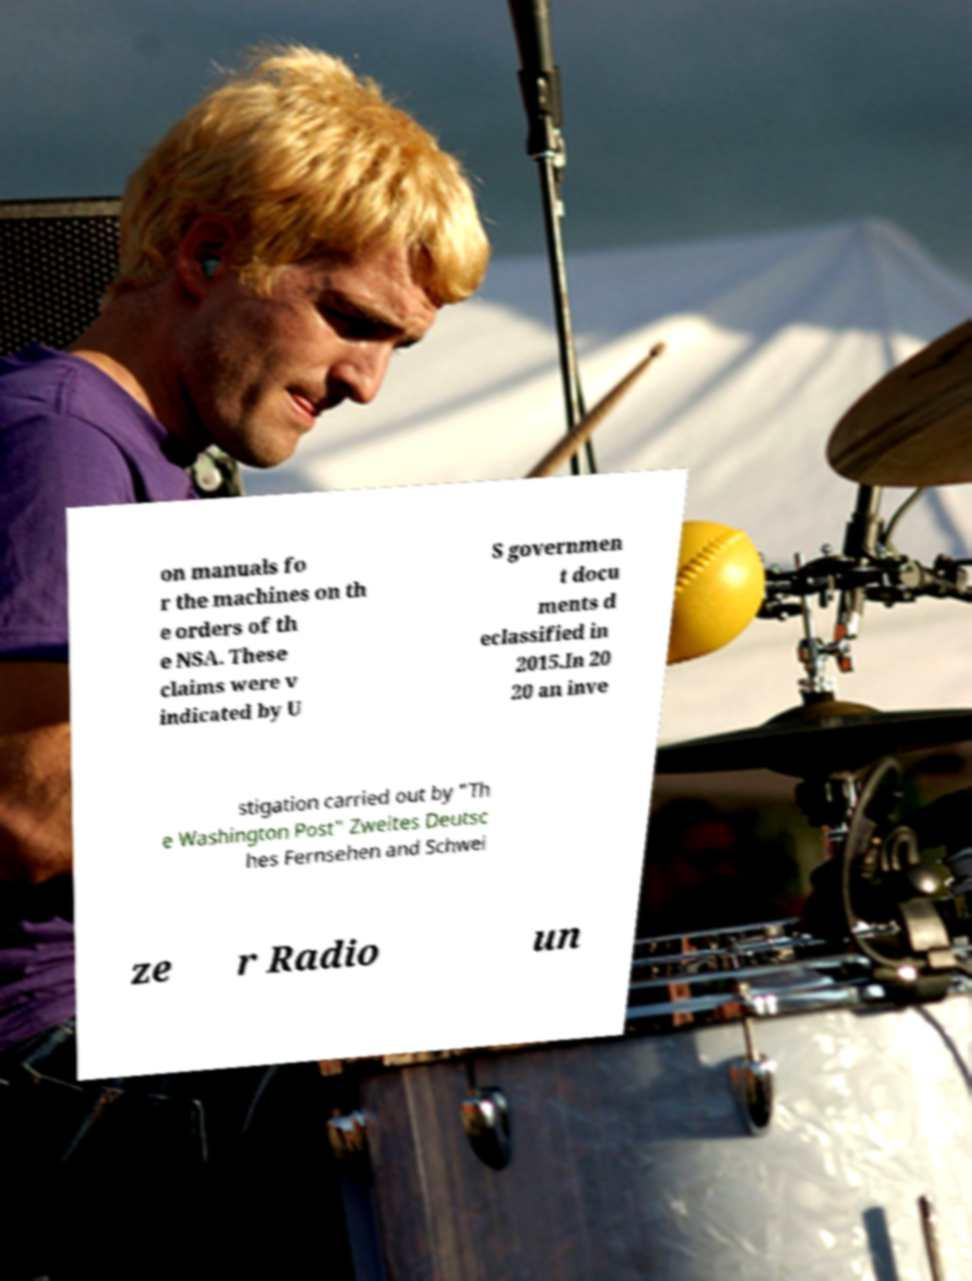Can you accurately transcribe the text from the provided image for me? on manuals fo r the machines on th e orders of th e NSA. These claims were v indicated by U S governmen t docu ments d eclassified in 2015.In 20 20 an inve stigation carried out by "Th e Washington Post" Zweites Deutsc hes Fernsehen and Schwei ze r Radio un 